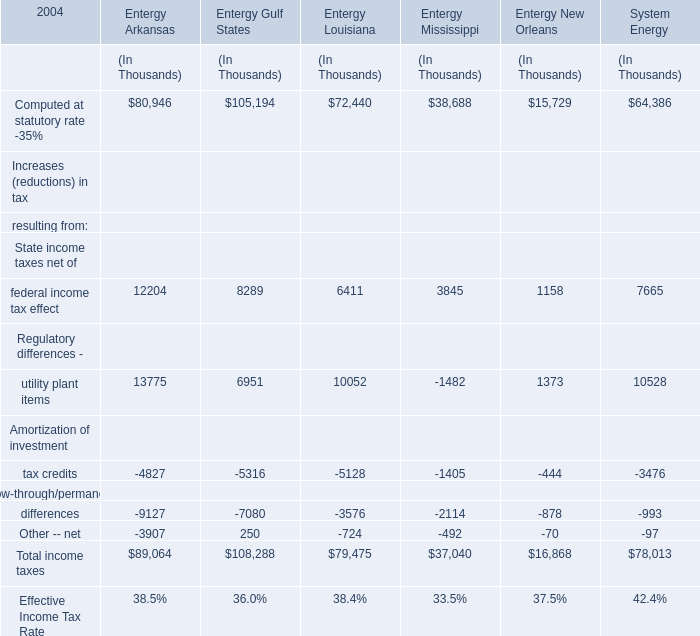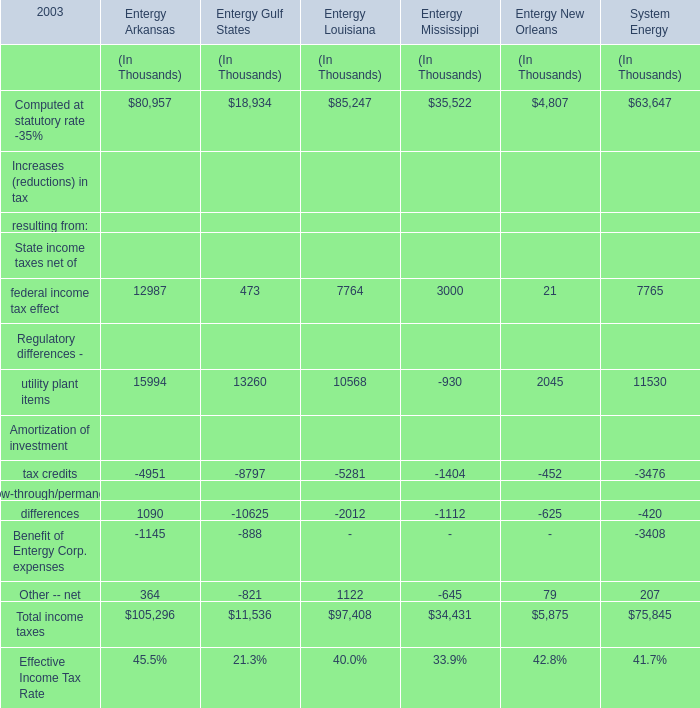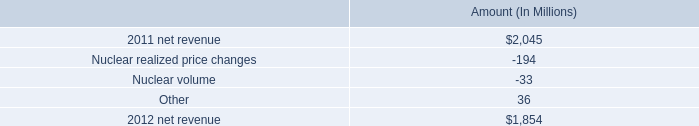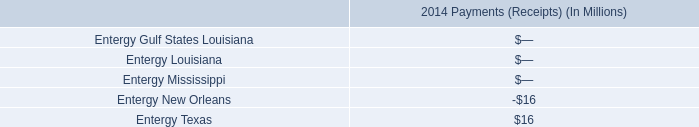what is the growth rate in net revenue for entergy wholesale commodities in 2012? 
Computations: ((1854 - 2045) / 2045)
Answer: -0.0934. 